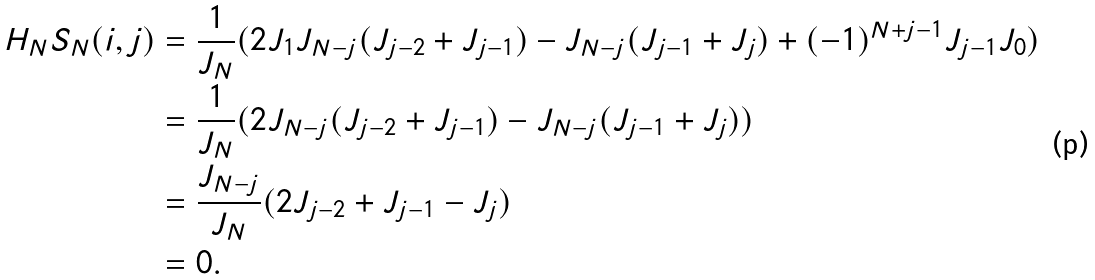Convert formula to latex. <formula><loc_0><loc_0><loc_500><loc_500>H _ { N } S _ { N } ( i , j ) & = \frac { 1 } { J _ { N } } ( 2 J _ { 1 } J _ { N - j } ( J _ { j - 2 } + J _ { j - 1 } ) - J _ { N - j } ( J _ { j - 1 } + J _ { j } ) + ( - 1 ) ^ { N + j - 1 } J _ { j - 1 } J _ { 0 } ) \\ & = \frac { 1 } { J _ { N } } ( 2 J _ { N - j } ( J _ { j - 2 } + J _ { j - 1 } ) - J _ { N - j } ( J _ { j - 1 } + J _ { j } ) ) \\ & = \frac { J _ { N - j } } { J _ { N } } ( 2 J _ { j - 2 } + J _ { j - 1 } - J _ { j } ) \\ & = 0 .</formula> 